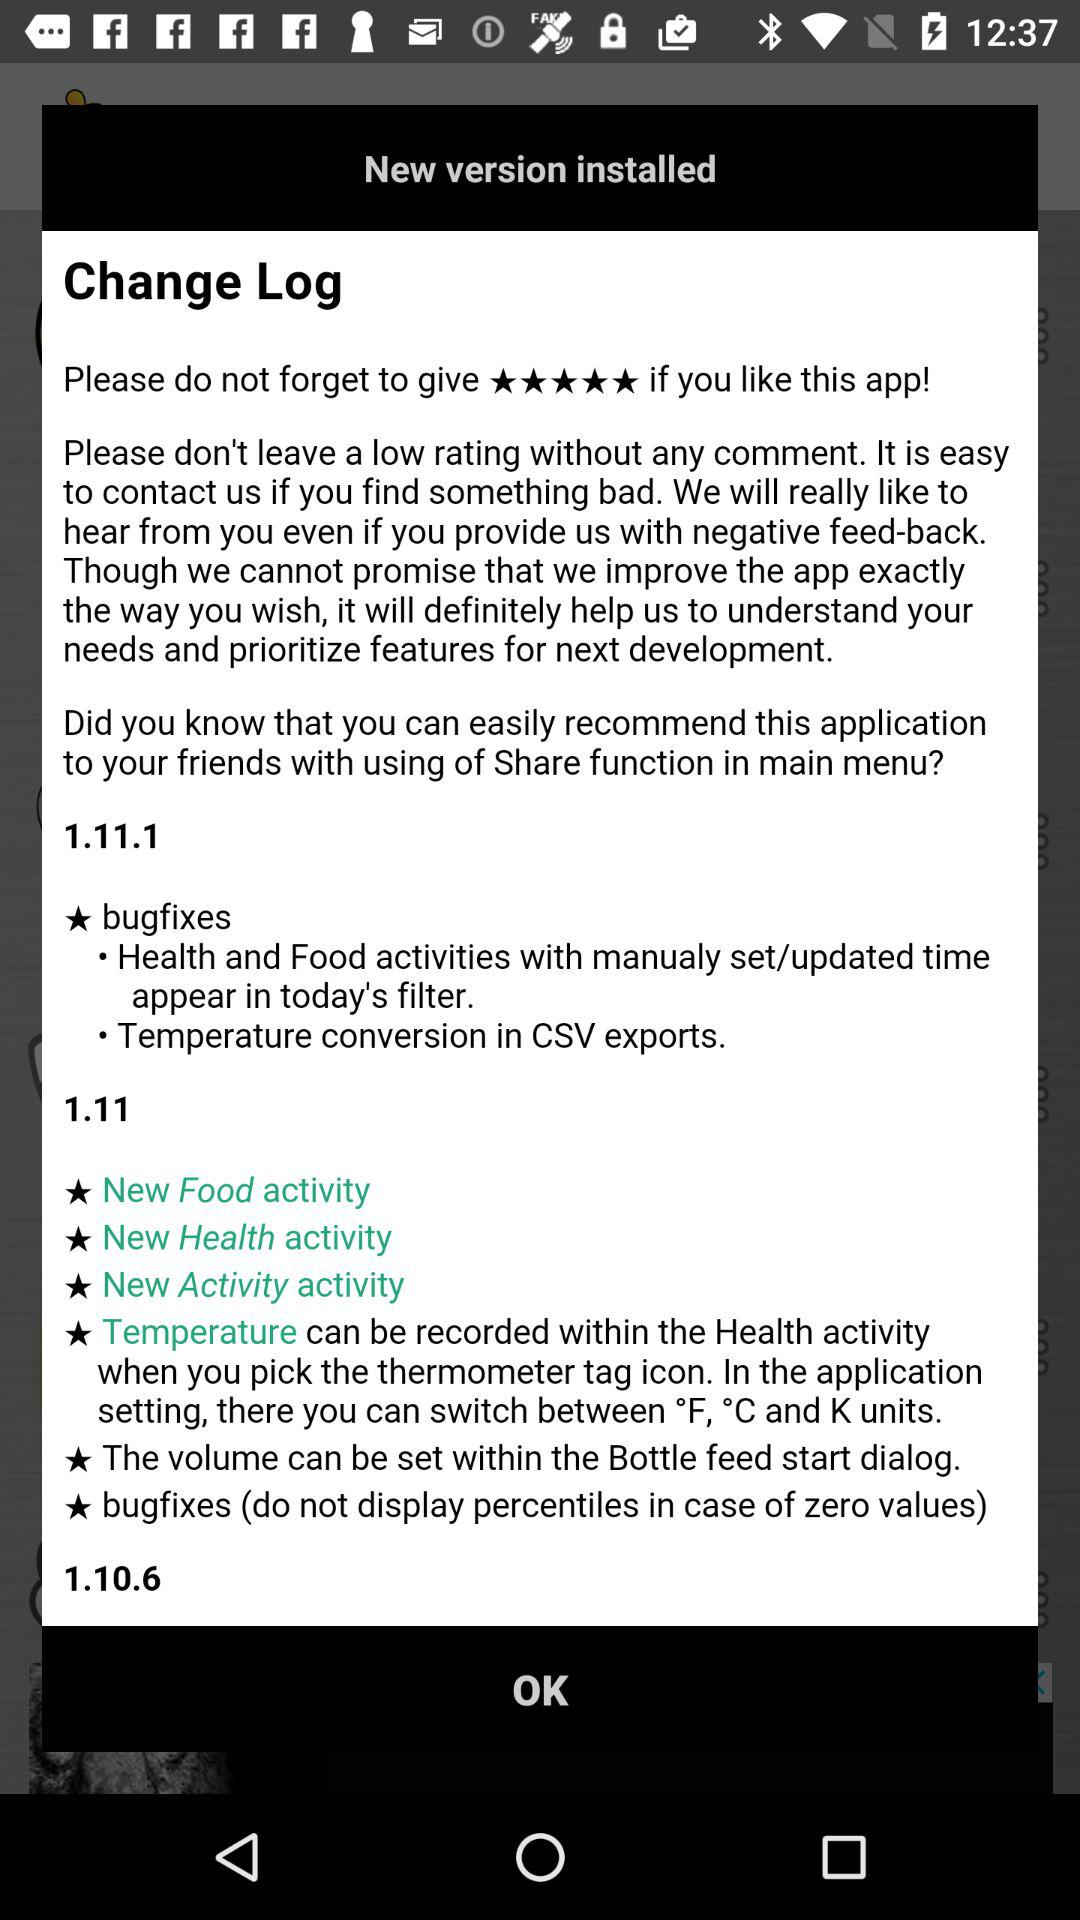How many bugfixes were added in version 1.11.1?
Answer the question using a single word or phrase. 2 